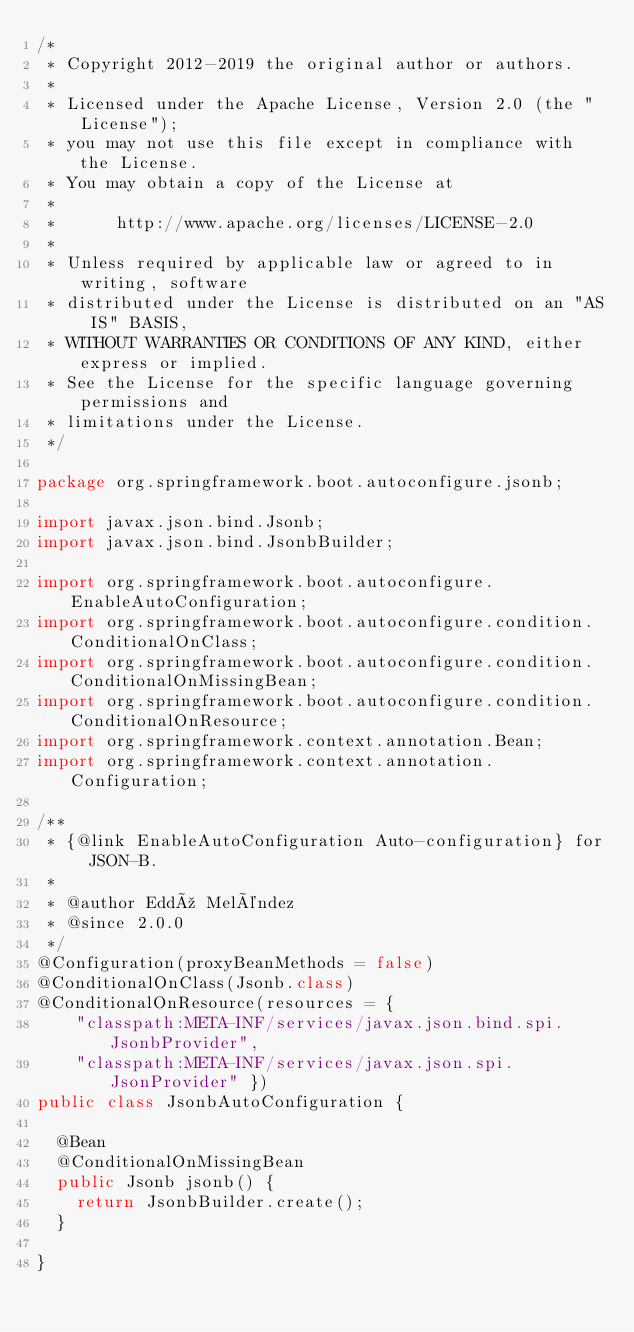Convert code to text. <code><loc_0><loc_0><loc_500><loc_500><_Java_>/*
 * Copyright 2012-2019 the original author or authors.
 *
 * Licensed under the Apache License, Version 2.0 (the "License");
 * you may not use this file except in compliance with the License.
 * You may obtain a copy of the License at
 *
 *      http://www.apache.org/licenses/LICENSE-2.0
 *
 * Unless required by applicable law or agreed to in writing, software
 * distributed under the License is distributed on an "AS IS" BASIS,
 * WITHOUT WARRANTIES OR CONDITIONS OF ANY KIND, either express or implied.
 * See the License for the specific language governing permissions and
 * limitations under the License.
 */

package org.springframework.boot.autoconfigure.jsonb;

import javax.json.bind.Jsonb;
import javax.json.bind.JsonbBuilder;

import org.springframework.boot.autoconfigure.EnableAutoConfiguration;
import org.springframework.boot.autoconfigure.condition.ConditionalOnClass;
import org.springframework.boot.autoconfigure.condition.ConditionalOnMissingBean;
import org.springframework.boot.autoconfigure.condition.ConditionalOnResource;
import org.springframework.context.annotation.Bean;
import org.springframework.context.annotation.Configuration;

/**
 * {@link EnableAutoConfiguration Auto-configuration} for JSON-B.
 *
 * @author Eddú Meléndez
 * @since 2.0.0
 */
@Configuration(proxyBeanMethods = false)
@ConditionalOnClass(Jsonb.class)
@ConditionalOnResource(resources = {
		"classpath:META-INF/services/javax.json.bind.spi.JsonbProvider",
		"classpath:META-INF/services/javax.json.spi.JsonProvider" })
public class JsonbAutoConfiguration {

	@Bean
	@ConditionalOnMissingBean
	public Jsonb jsonb() {
		return JsonbBuilder.create();
	}

}
</code> 